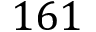<formula> <loc_0><loc_0><loc_500><loc_500>1 6 1</formula> 